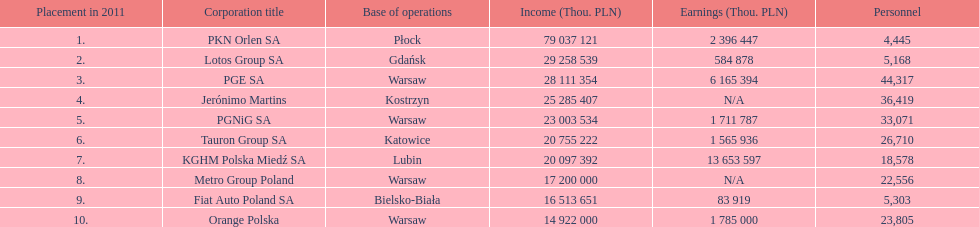What are the names of all the concerns? PKN Orlen SA, Lotos Group SA, PGE SA, Jerónimo Martins, PGNiG SA, Tauron Group SA, KGHM Polska Miedź SA, Metro Group Poland, Fiat Auto Poland SA, Orange Polska. How many employees does pgnig sa have? 33,071. 